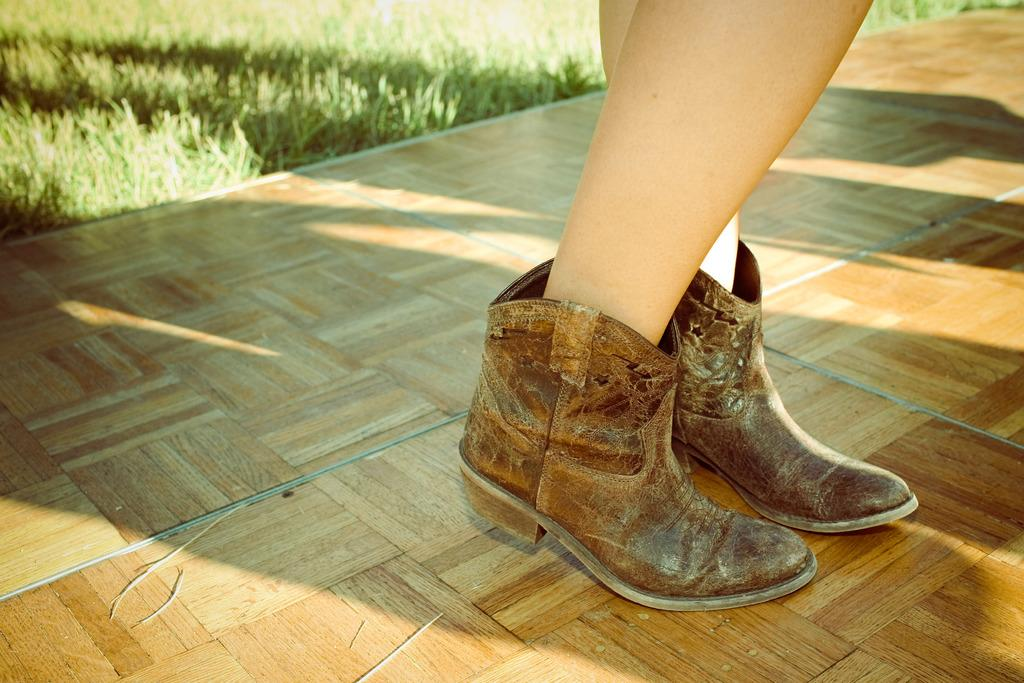What body part is visible in the image? The image shows human legs. What are the human legs wearing? The human legs have shoes on them. What color are the shoes? The shoes are brown in color. What type of surface is visible beneath the human legs? There is grass visible on the ground. What type of books can be seen in the library in the image? There is no library or books present in the image; it only shows human legs with brown shoes and grass on the ground. 